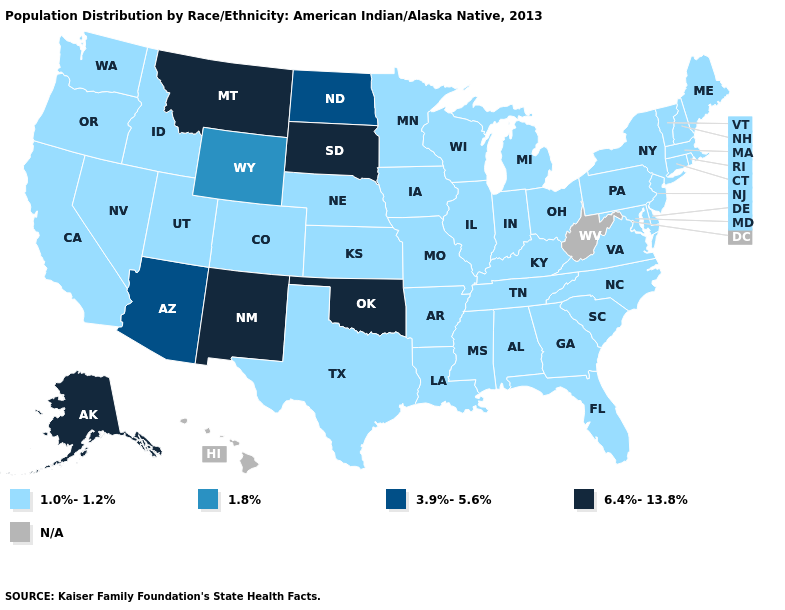Does Oklahoma have the highest value in the USA?
Write a very short answer. Yes. What is the lowest value in the MidWest?
Keep it brief. 1.0%-1.2%. Name the states that have a value in the range 1.8%?
Keep it brief. Wyoming. How many symbols are there in the legend?
Concise answer only. 5. Name the states that have a value in the range 3.9%-5.6%?
Concise answer only. Arizona, North Dakota. Does Nebraska have the lowest value in the USA?
Write a very short answer. Yes. Does Wyoming have the lowest value in the USA?
Quick response, please. No. What is the value of Ohio?
Quick response, please. 1.0%-1.2%. Which states have the highest value in the USA?
Quick response, please. Alaska, Montana, New Mexico, Oklahoma, South Dakota. Name the states that have a value in the range 1.8%?
Short answer required. Wyoming. Which states have the highest value in the USA?
Give a very brief answer. Alaska, Montana, New Mexico, Oklahoma, South Dakota. Is the legend a continuous bar?
Be succinct. No. Name the states that have a value in the range 1.0%-1.2%?
Concise answer only. Alabama, Arkansas, California, Colorado, Connecticut, Delaware, Florida, Georgia, Idaho, Illinois, Indiana, Iowa, Kansas, Kentucky, Louisiana, Maine, Maryland, Massachusetts, Michigan, Minnesota, Mississippi, Missouri, Nebraska, Nevada, New Hampshire, New Jersey, New York, North Carolina, Ohio, Oregon, Pennsylvania, Rhode Island, South Carolina, Tennessee, Texas, Utah, Vermont, Virginia, Washington, Wisconsin. What is the value of Utah?
Write a very short answer. 1.0%-1.2%. 